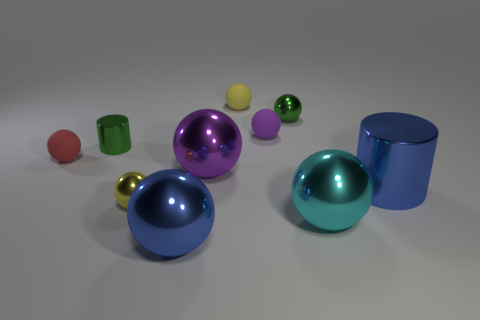Are there more large cyan matte cubes than purple metal things?
Your response must be concise. No. What color is the matte ball that is in front of the green object that is left of the blue shiny object that is left of the small purple matte ball?
Offer a very short reply. Red. Is the color of the small matte thing that is to the left of the big blue ball the same as the big metal object to the right of the cyan metallic thing?
Provide a succinct answer. No. What number of blue things are to the right of the large thing that is behind the big cylinder?
Your answer should be compact. 1. Is there a big blue metal object?
Give a very brief answer. Yes. What number of other things are the same color as the large metallic cylinder?
Keep it short and to the point. 1. Are there fewer small purple rubber cylinders than big blue objects?
Provide a short and direct response. Yes. There is a blue thing left of the small yellow object that is behind the purple matte object; what is its shape?
Make the answer very short. Sphere. There is a large cylinder; are there any large cyan things right of it?
Offer a very short reply. No. There is a metal cylinder that is the same size as the purple matte thing; what is its color?
Your response must be concise. Green. 